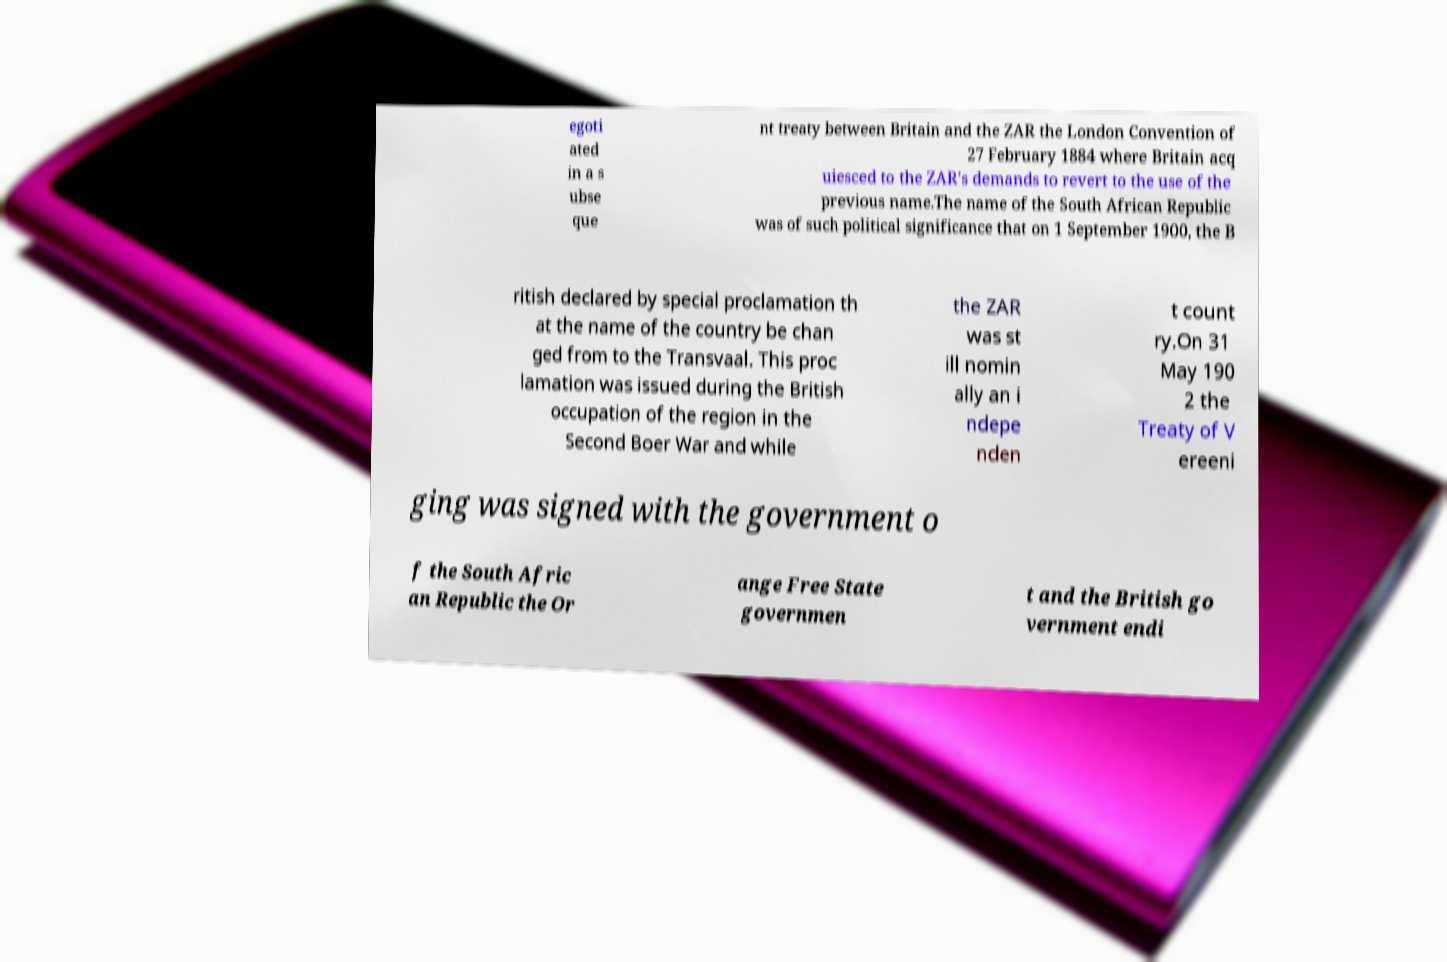Can you accurately transcribe the text from the provided image for me? egoti ated in a s ubse que nt treaty between Britain and the ZAR the London Convention of 27 February 1884 where Britain acq uiesced to the ZAR's demands to revert to the use of the previous name.The name of the South African Republic was of such political significance that on 1 September 1900, the B ritish declared by special proclamation th at the name of the country be chan ged from to the Transvaal. This proc lamation was issued during the British occupation of the region in the Second Boer War and while the ZAR was st ill nomin ally an i ndepe nden t count ry.On 31 May 190 2 the Treaty of V ereeni ging was signed with the government o f the South Afric an Republic the Or ange Free State governmen t and the British go vernment endi 